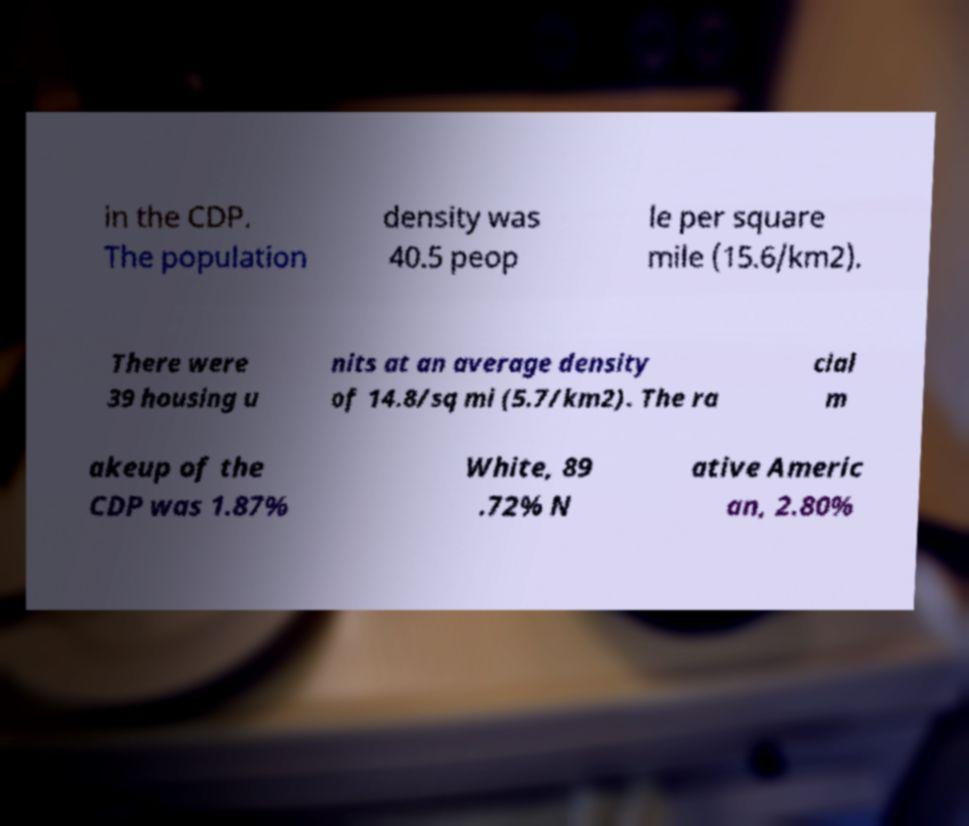I need the written content from this picture converted into text. Can you do that? in the CDP. The population density was 40.5 peop le per square mile (15.6/km2). There were 39 housing u nits at an average density of 14.8/sq mi (5.7/km2). The ra cial m akeup of the CDP was 1.87% White, 89 .72% N ative Americ an, 2.80% 